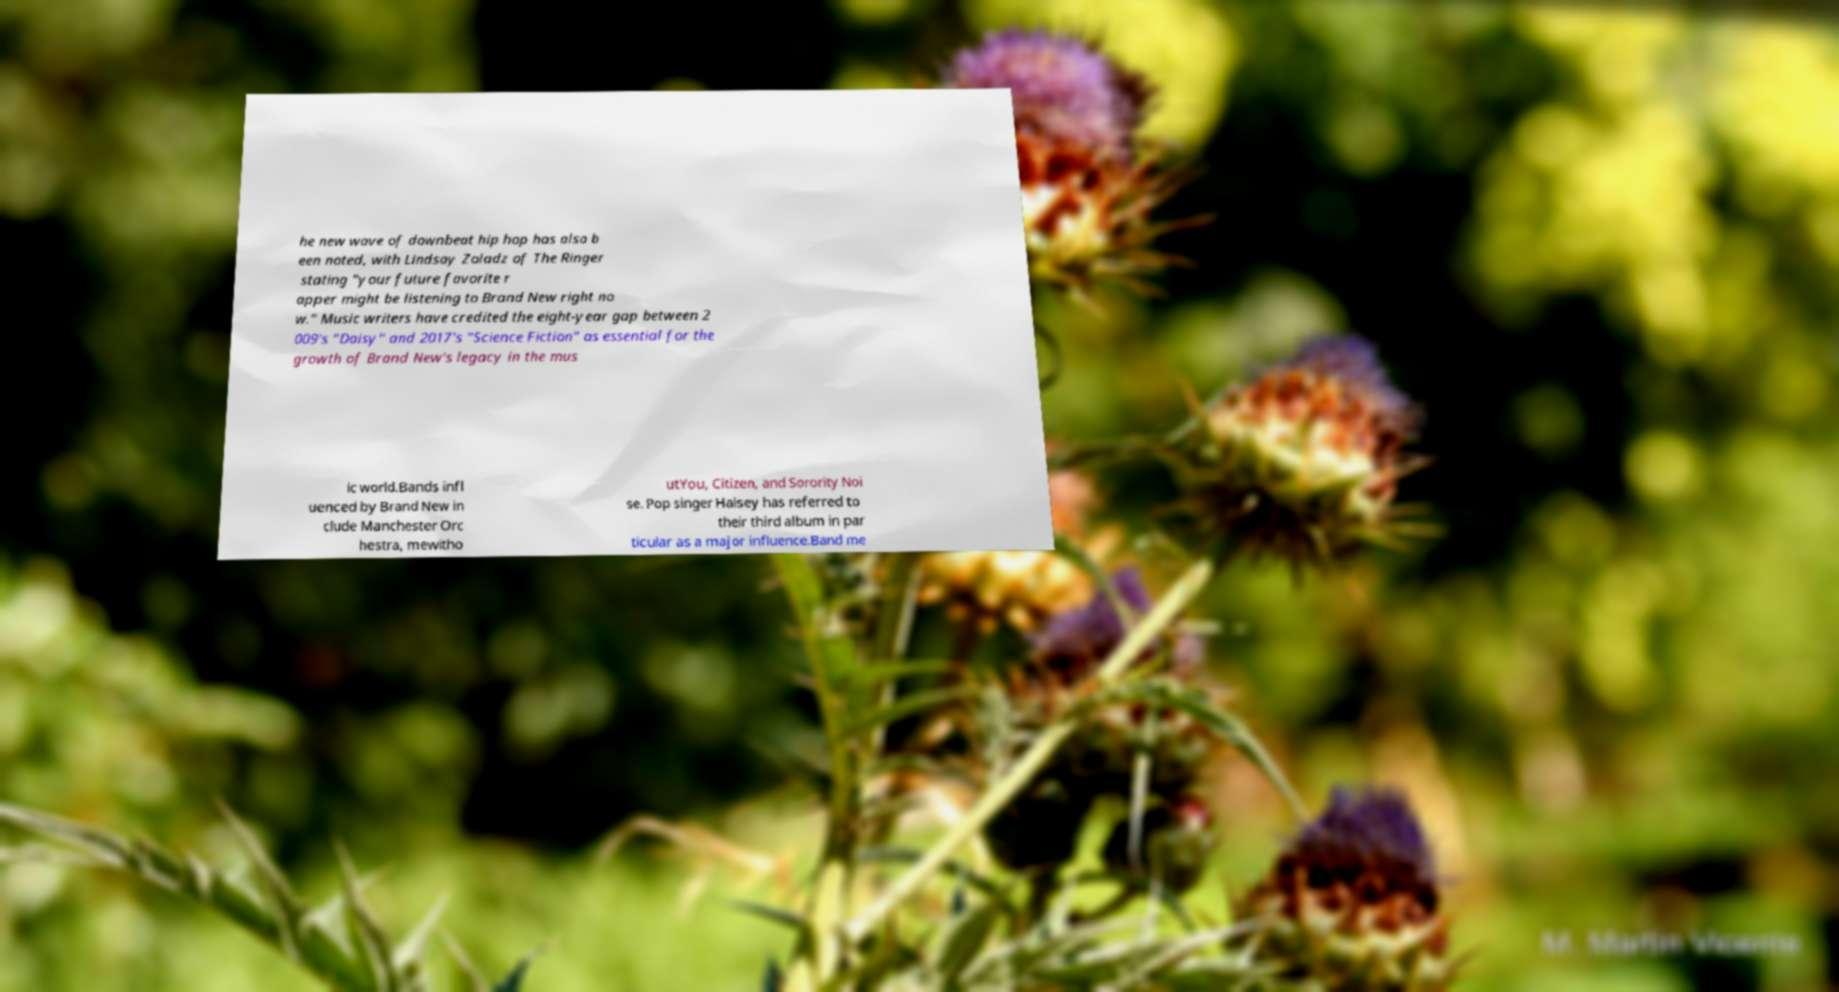I need the written content from this picture converted into text. Can you do that? he new wave of downbeat hip hop has also b een noted, with Lindsay Zoladz of The Ringer stating "your future favorite r apper might be listening to Brand New right no w." Music writers have credited the eight-year gap between 2 009's "Daisy" and 2017's "Science Fiction" as essential for the growth of Brand New's legacy in the mus ic world.Bands infl uenced by Brand New in clude Manchester Orc hestra, mewitho utYou, Citizen, and Sorority Noi se. Pop singer Halsey has referred to their third album in par ticular as a major influence.Band me 